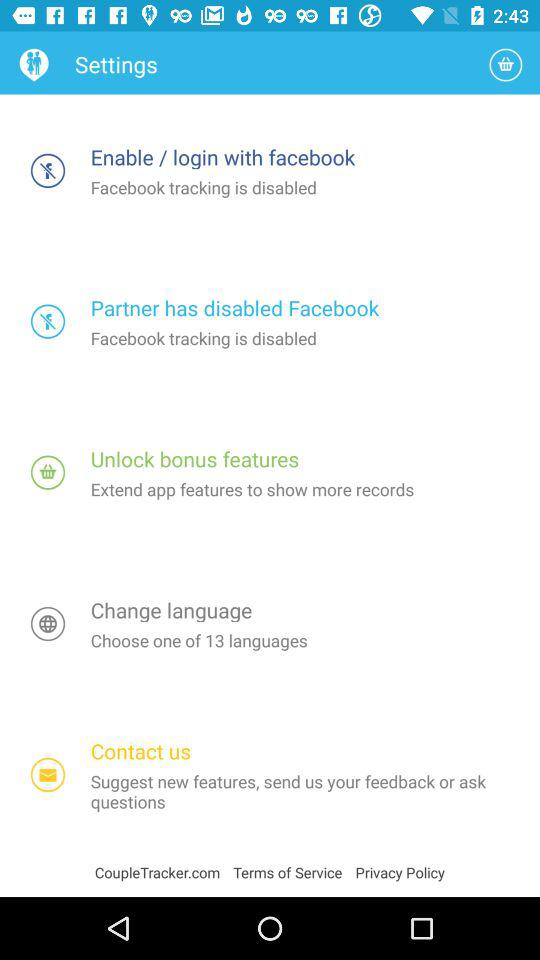How many languages are there in the "Change language" option? There are 13 languages. 